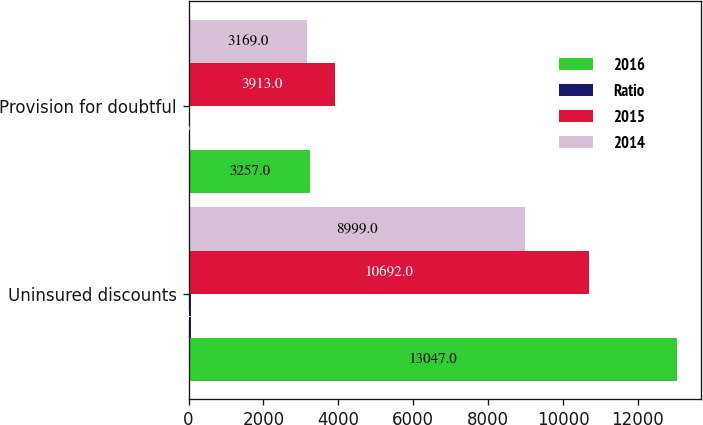Convert chart. <chart><loc_0><loc_0><loc_500><loc_500><stacked_bar_chart><ecel><fcel>Uninsured discounts<fcel>Provision for doubtful<nl><fcel>2016<fcel>13047<fcel>3257<nl><fcel>Ratio<fcel>64<fcel>16<nl><fcel>2015<fcel>10692<fcel>3913<nl><fcel>2014<fcel>8999<fcel>3169<nl></chart> 